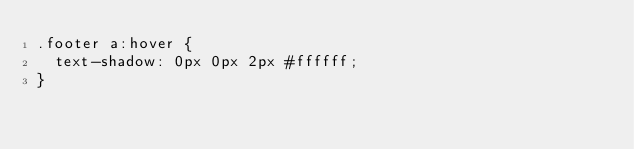Convert code to text. <code><loc_0><loc_0><loc_500><loc_500><_CSS_>.footer a:hover {
  text-shadow: 0px 0px 2px #ffffff;
}
</code> 